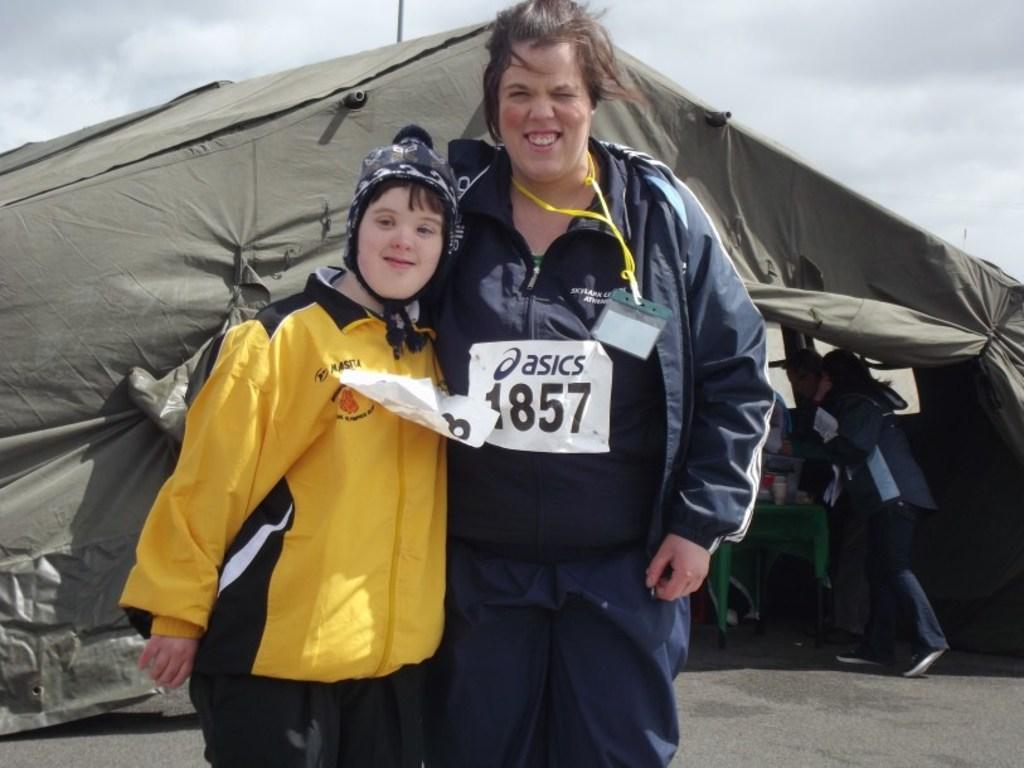In one or two sentences, can you explain what this image depicts? In this picture, there is a woman wearing a blue jacket and black trousers and she is holding a kid wearing a yellow jacket. Behind them, there is a tent. Under the tent, there is a woman and a table. In the background there is a sky with clouds. 